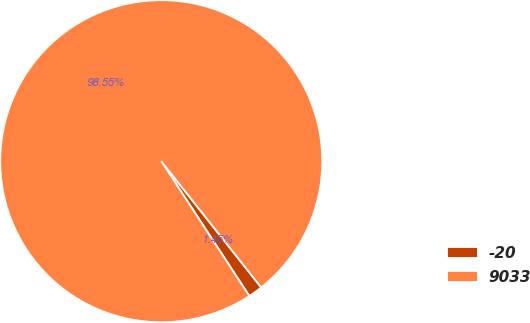<chart> <loc_0><loc_0><loc_500><loc_500><pie_chart><fcel>-20<fcel>9033<nl><fcel>1.45%<fcel>98.55%<nl></chart> 